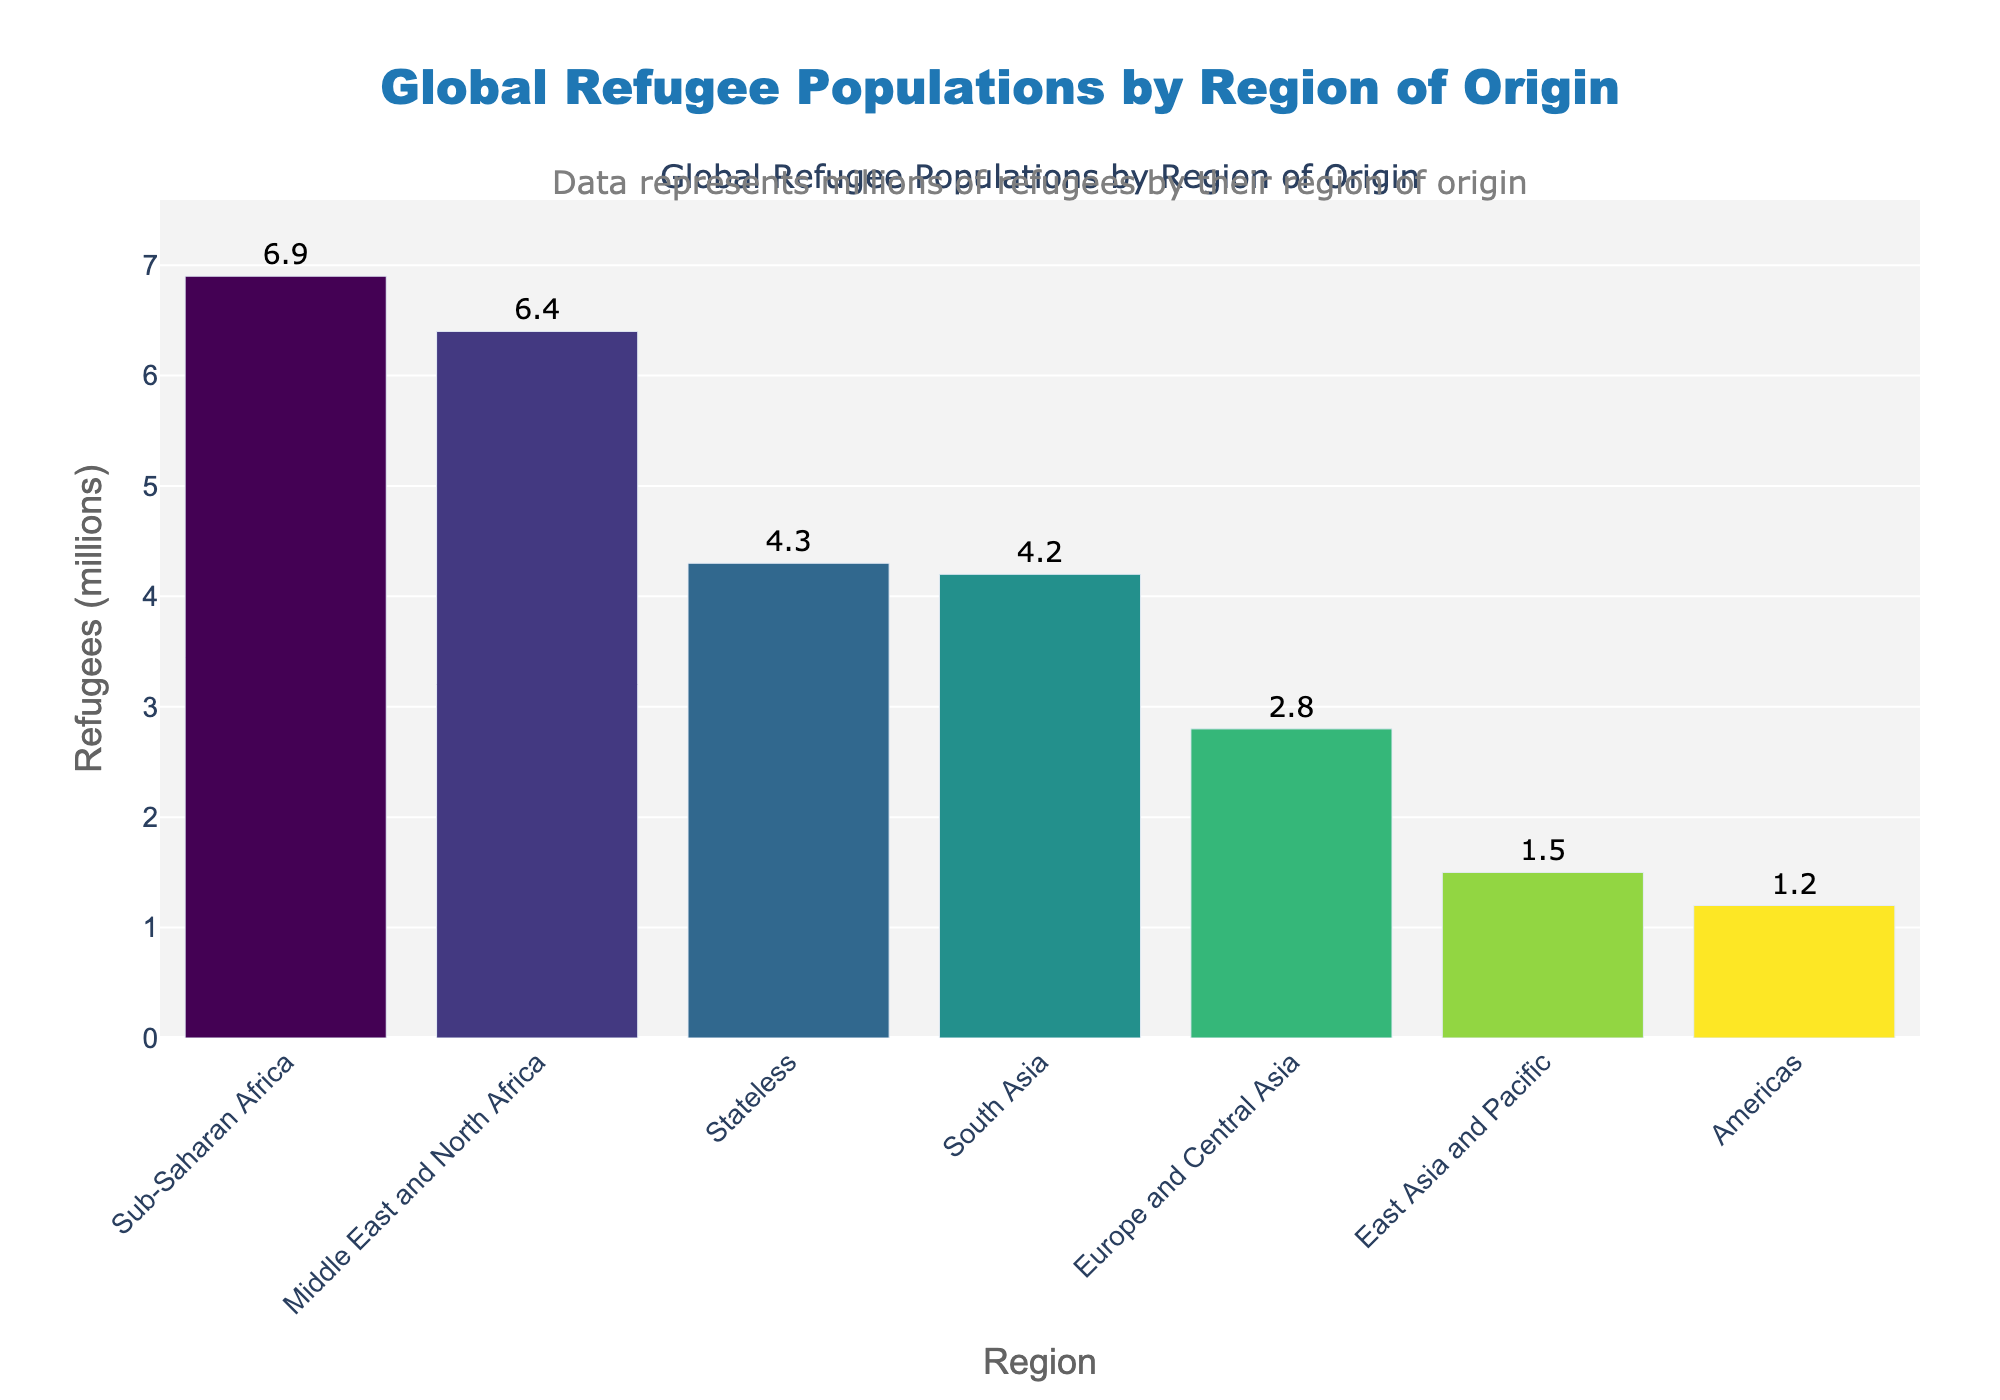What region has the highest number of refugees? By examining the lengths of the bars, we can see that the bar for Sub-Saharan Africa is the longest, indicating it has the highest number of refugees.
Answer: Sub-Saharan Africa Which regions have more than 4 million refugees? To determine this, we look for bars that extend beyond the 4 million mark on the y-axis. The regions that meet this criterion are Sub-Saharan Africa, Middle East and North Africa, South Asia, and Stateless.
Answer: Sub-Saharan Africa, Middle East and North Africa, South Asia, Stateless How many more refugees does Sub-Saharan Africa have compared to the Americas? Sub-Saharan Africa has 6.9 million refugees, whereas the Americas have 1.2 million. Subtracting the two gives us 6.9 - 1.2 = 5.7 million more refugees.
Answer: 5.7 million Which region has the lowest number of refugees? By comparing the lengths of the bars, we find that the bar for the Americas is the shortest, indicating it has the lowest number of refugees.
Answer: Americas What is the combined total of refugees from Middle East and North Africa, and South Asia? Adding the number of refugees from both regions: 6.4 million (Middle East and North Africa) + 4.2 million (South Asia) = 10.6 million.
Answer: 10.6 million How many regions have fewer refugees than Stateless people? Stateless people are represented by 4.3 million refugees. The regions with fewer refugees than Stateless are Europe and Central Asia, East Asia and Pacific, and Americas. There are 3 such regions.
Answer: 3 regions Which regions have more refugees: Europe and Central Asia combined with East Asia and Pacific, or South Asia alone? Adding Europe and Central Asia (2.8 million) plus East Asia and Pacific (1.5 million) gives us 2.8 + 1.5 = 4.3 million. South Asia alone has 4.2 million refugees. 4.3 million is slightly more than 4.2 million.
Answer: Europe and Central Asia combined with East Asia and Pacific What is the average number of refugees across all regions except Stateless? First, add the number of refugees in all the regions except Stateless: 6.9 + 6.4 + 4.2 + 2.8 + 1.5 + 1.2 = 23.0 million. Then, divide this sum by 6 (the number of regions): 23.0 / 6 ≈ 3.83 million.
Answer: 3.83 million What is the difference in refugee numbers between the third and fourth highest regions? The third highest region is South Asia with 4.2 million refugees, and the fourth highest is Europe and Central Asia with 2.8 million refugees. The difference is 4.2 - 2.8 = 1.4 million.
Answer: 1.4 million 